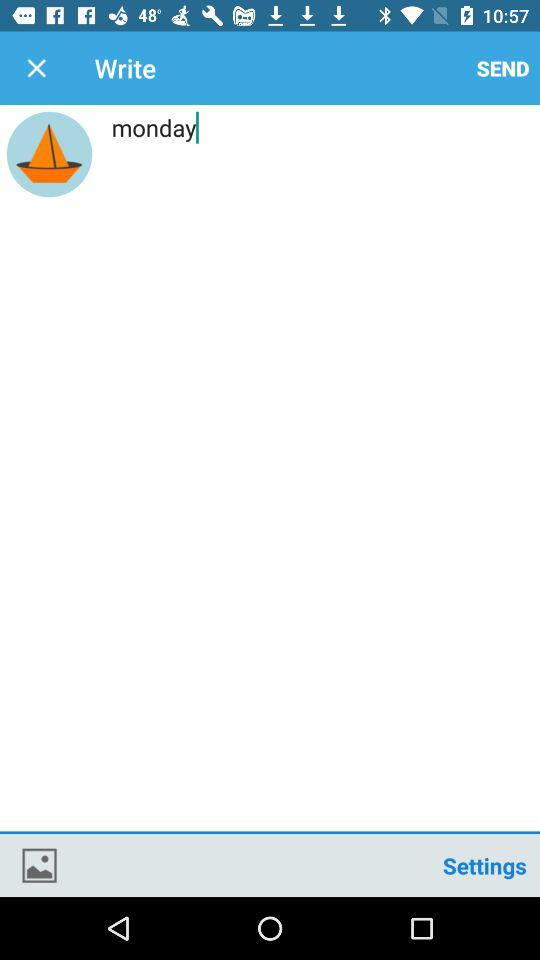What day is written on the screen? The day is written on the screen as Monday. 